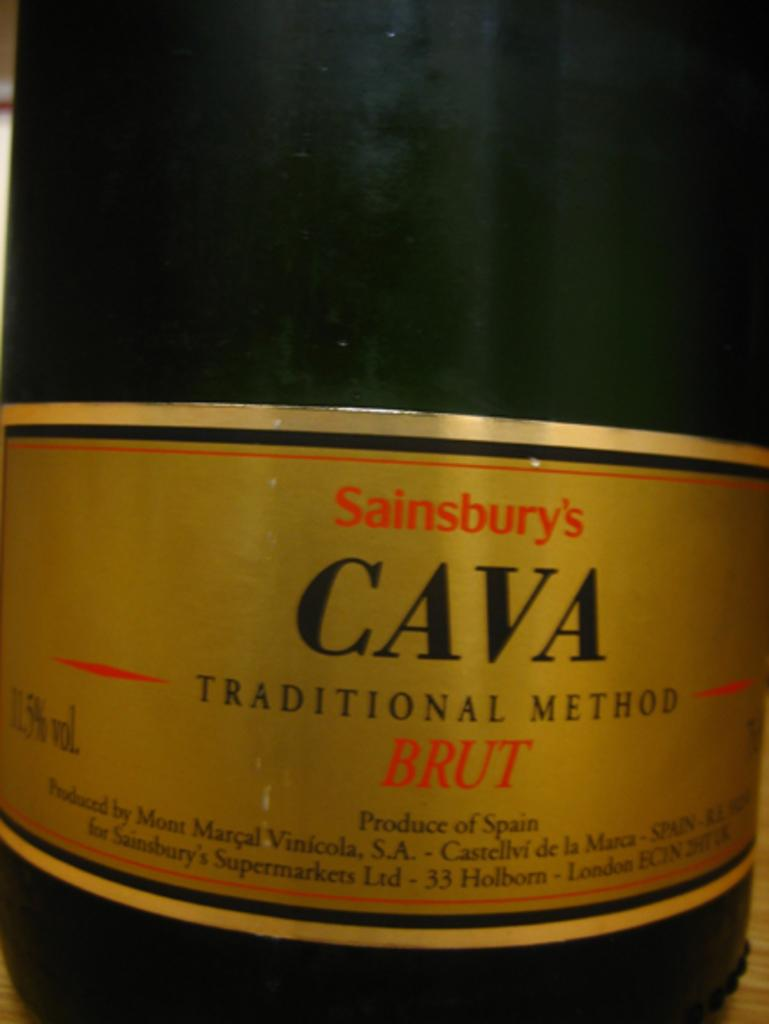Provide a one-sentence caption for the provided image. A bottle of Sainsbury's Cava done by the traditional method. 